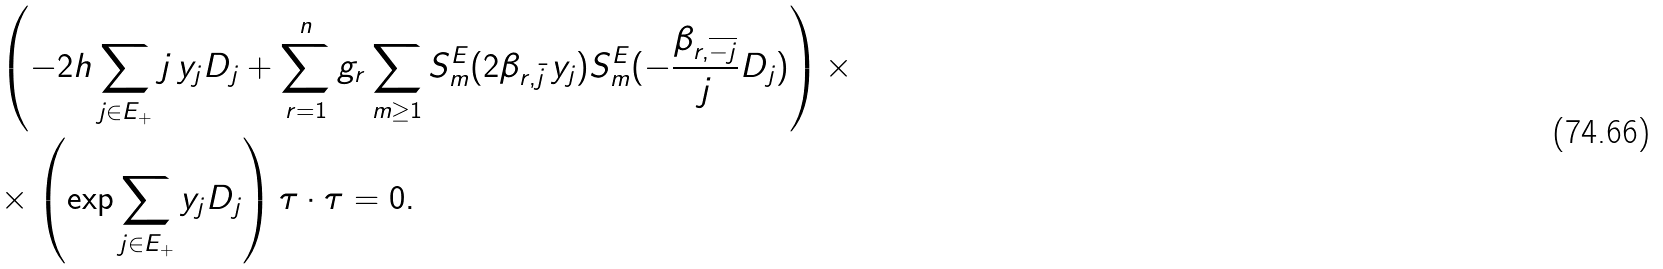Convert formula to latex. <formula><loc_0><loc_0><loc_500><loc_500>& \left ( - 2 h \sum _ { j \in E _ { + } } j \, y _ { j } D _ { j } + \sum _ { r = 1 } ^ { n } g _ { r } \sum _ { m \geq 1 } S _ { m } ^ { E } ( 2 \beta _ { r , \bar { j } } \, y _ { j } ) S _ { m } ^ { E } ( - \frac { \beta _ { r , \overline { - j } } } { j } D _ { j } ) \right ) \times \\ & \times \left ( \exp \sum _ { j \in E _ { + } } y _ { j } D _ { j } \right ) \tau \cdot \tau = 0 .</formula> 